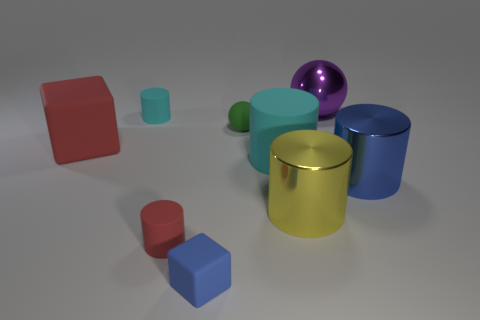Does the cube in front of the big red matte block have the same material as the blue cylinder?
Provide a succinct answer. No. Are there an equal number of big yellow metal objects in front of the small rubber block and tiny spheres to the left of the tiny cyan rubber object?
Offer a terse response. Yes. Are there any other things that have the same size as the purple ball?
Keep it short and to the point. Yes. What is the material of the small red thing that is the same shape as the big yellow object?
Give a very brief answer. Rubber. Is there a small matte block that is to the right of the object that is to the right of the purple metallic object that is right of the small green matte ball?
Provide a succinct answer. No. There is a blue thing in front of the yellow thing; is it the same shape as the shiny object that is behind the big blue thing?
Provide a succinct answer. No. Are there more tiny green spheres that are in front of the big cyan matte cylinder than small cubes?
Give a very brief answer. No. How many objects are either tiny yellow shiny spheres or cubes?
Give a very brief answer. 2. What color is the big rubber cylinder?
Keep it short and to the point. Cyan. What number of other objects are there of the same color as the big ball?
Your answer should be compact. 0. 